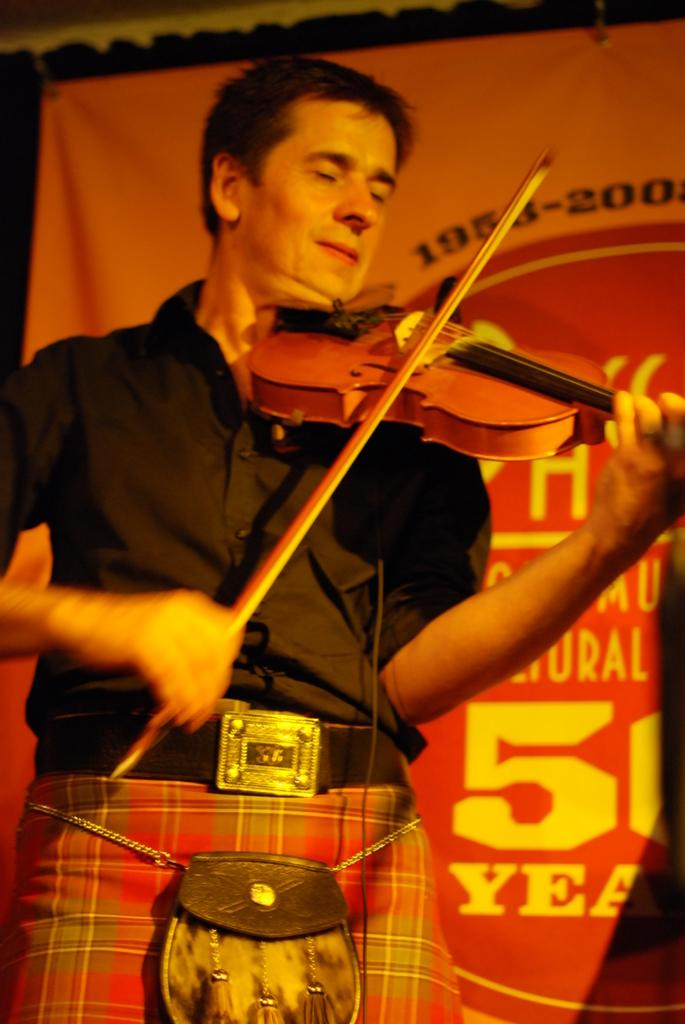What is the main subject of the picture? The main subject of the picture is a man. What is the man wearing? The man is wearing a black shirt. What is the man holding in his hand? The man is holding a violin in his hand. What is the man doing with the violin? The man is playing the violin. What can be seen behind the man in the picture? There is a banner with text visible behind the man. What type of coal can be seen in the man's ear in the image? There is no coal or any object in the man's ear in the image. What is the aftermath of the man's performance in the image? The image does not show the aftermath of the man's performance; it only captures the moment when he is playing the violin. 